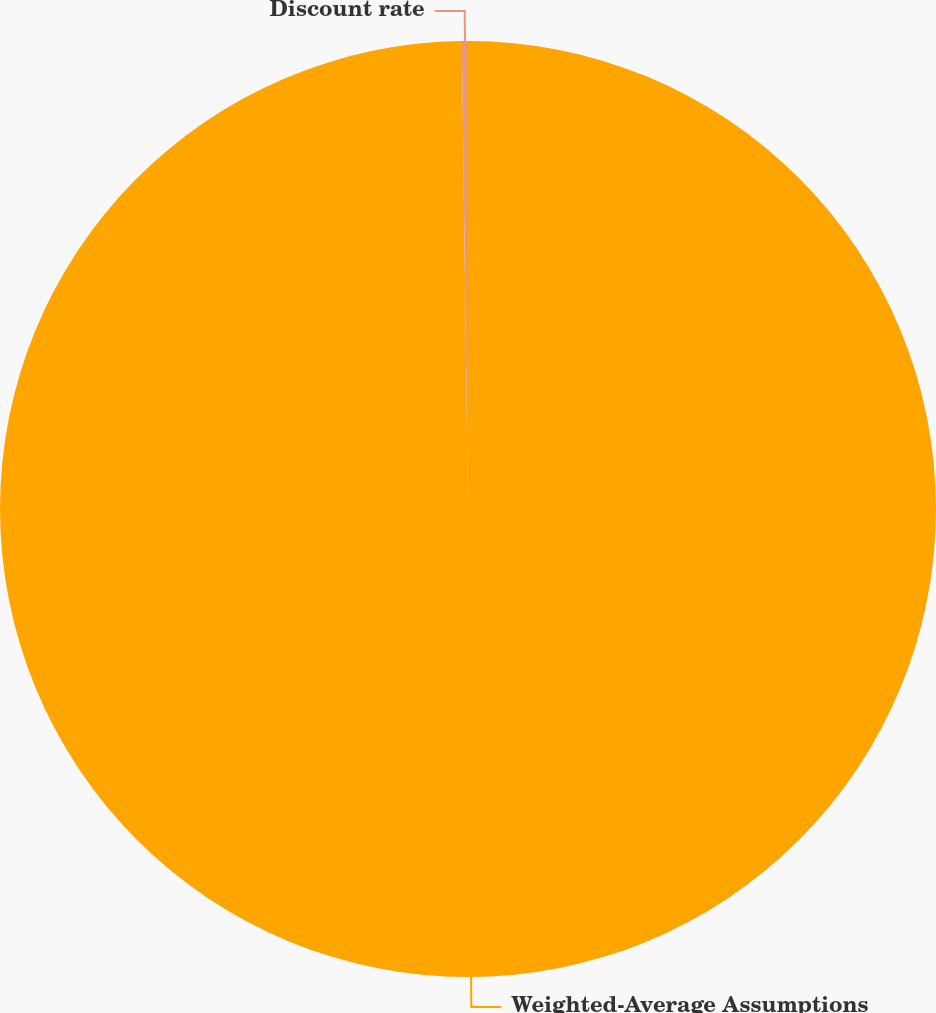Convert chart to OTSL. <chart><loc_0><loc_0><loc_500><loc_500><pie_chart><fcel>Weighted-Average Assumptions<fcel>Discount rate<nl><fcel>99.79%<fcel>0.21%<nl></chart> 